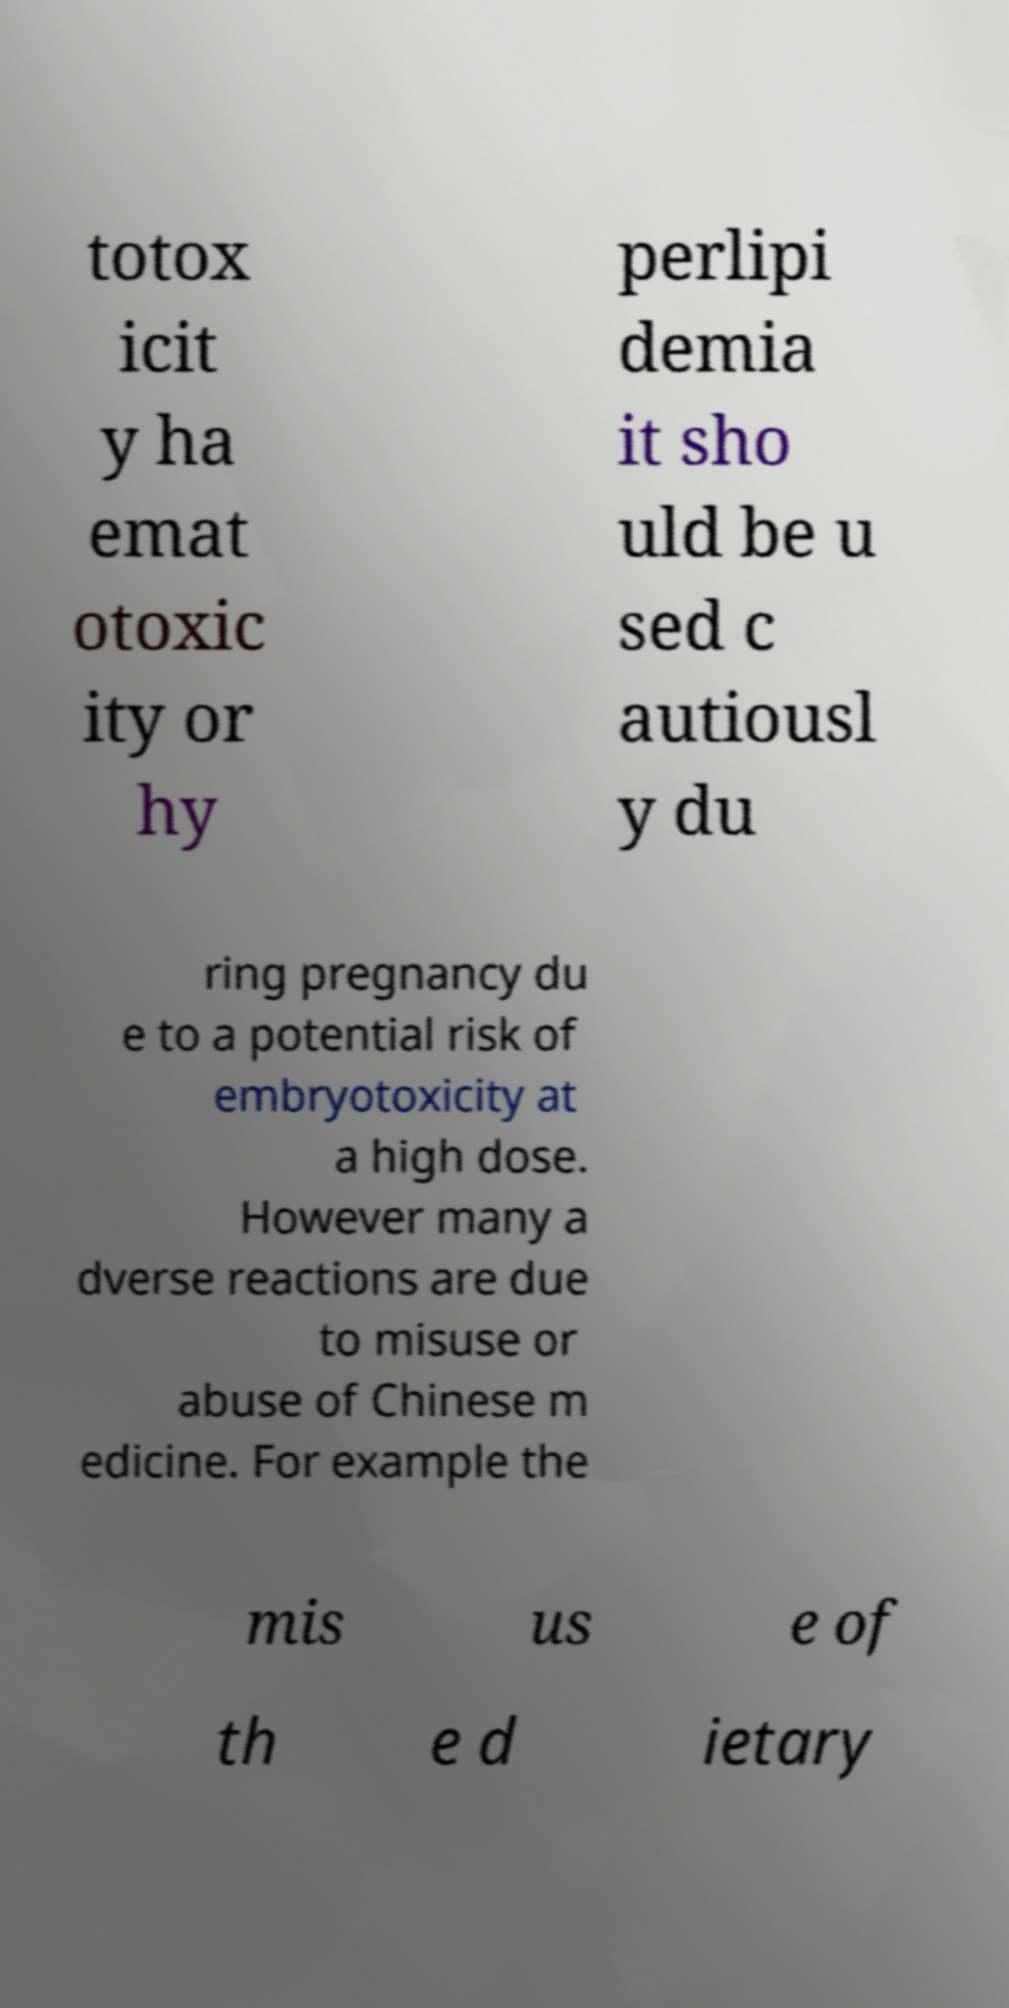Please identify and transcribe the text found in this image. totox icit y ha emat otoxic ity or hy perlipi demia it sho uld be u sed c autiousl y du ring pregnancy du e to a potential risk of embryotoxicity at a high dose. However many a dverse reactions are due to misuse or abuse of Chinese m edicine. For example the mis us e of th e d ietary 